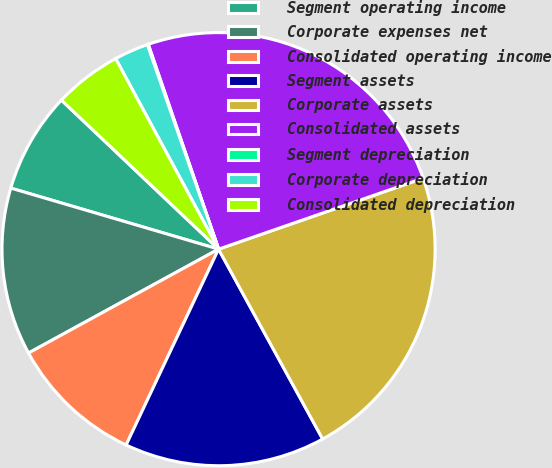Convert chart. <chart><loc_0><loc_0><loc_500><loc_500><pie_chart><fcel>Segment operating income<fcel>Corporate expenses net<fcel>Consolidated operating income<fcel>Segment assets<fcel>Corporate assets<fcel>Consolidated assets<fcel>Segment depreciation<fcel>Corporate depreciation<fcel>Consolidated depreciation<nl><fcel>7.53%<fcel>12.51%<fcel>10.02%<fcel>15.0%<fcel>22.33%<fcel>24.95%<fcel>0.07%<fcel>2.55%<fcel>5.04%<nl></chart> 